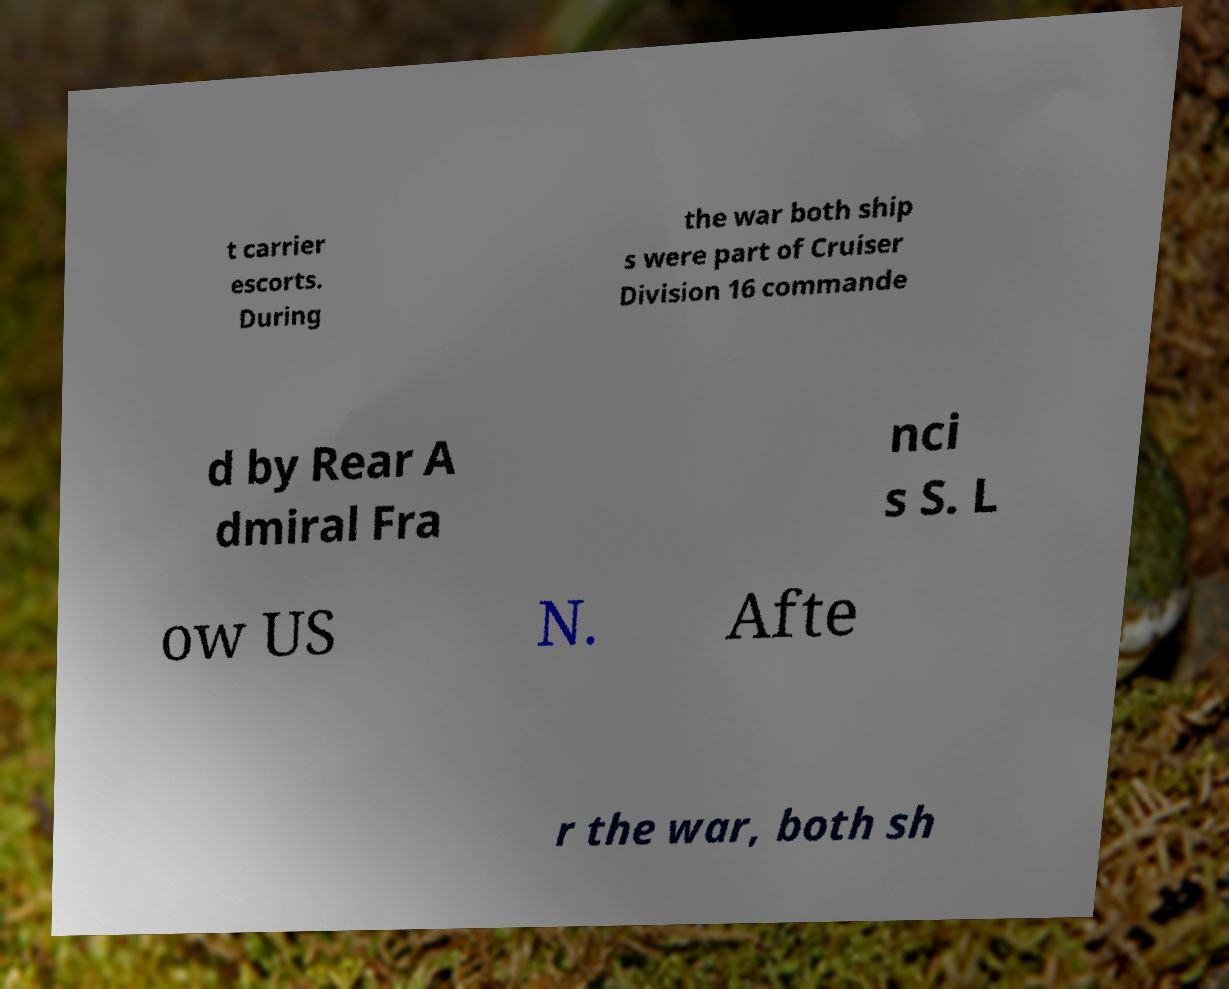There's text embedded in this image that I need extracted. Can you transcribe it verbatim? t carrier escorts. During the war both ship s were part of Cruiser Division 16 commande d by Rear A dmiral Fra nci s S. L ow US N. Afte r the war, both sh 